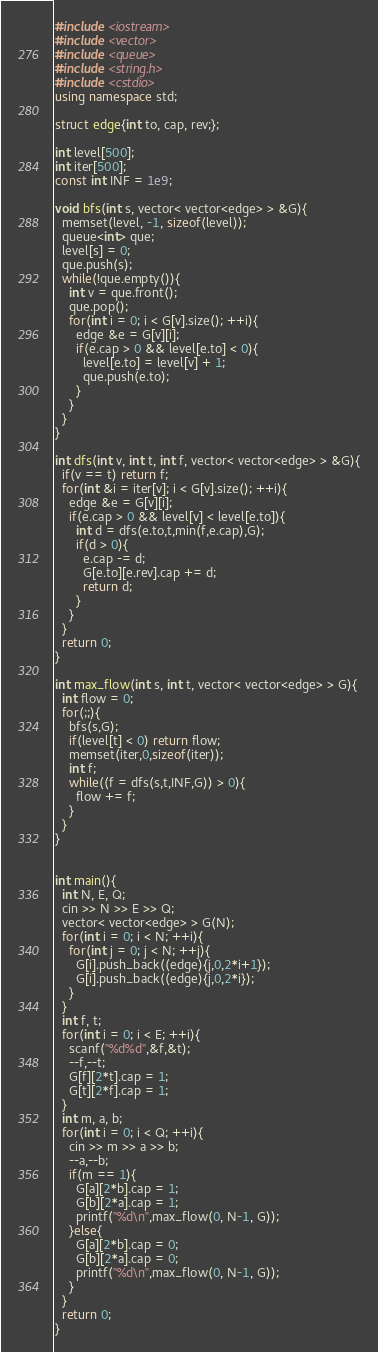<code> <loc_0><loc_0><loc_500><loc_500><_C++_>#include <iostream>
#include <vector>
#include <queue>
#include <string.h>
#include <cstdio>
using namespace std;

struct edge{int to, cap, rev;};

int level[500];
int iter[500];
const int INF = 1e9;

void bfs(int s, vector< vector<edge> > &G){
  memset(level, -1, sizeof(level));
  queue<int> que;
  level[s] = 0;
  que.push(s);
  while(!que.empty()){
    int v = que.front();
    que.pop();
    for(int i = 0; i < G[v].size(); ++i){
      edge &e = G[v][i];
      if(e.cap > 0 && level[e.to] < 0){
        level[e.to] = level[v] + 1;
        que.push(e.to);
      }
    }
  }
}

int dfs(int v, int t, int f, vector< vector<edge> > &G){
  if(v == t) return f;
  for(int &i = iter[v]; i < G[v].size(); ++i){
    edge &e = G[v][i];
    if(e.cap > 0 && level[v] < level[e.to]){
      int d = dfs(e.to,t,min(f,e.cap),G);
      if(d > 0){
        e.cap -= d;
        G[e.to][e.rev].cap += d;
        return d;
      }
    }
  }
  return 0;
}

int max_flow(int s, int t, vector< vector<edge> > G){
  int flow = 0;
  for(;;){
    bfs(s,G);
    if(level[t] < 0) return flow;
    memset(iter,0,sizeof(iter));
    int f;
    while((f = dfs(s,t,INF,G)) > 0){
      flow += f;
    }
  }
}


int main(){
  int N, E, Q;
  cin >> N >> E >> Q;
  vector< vector<edge> > G(N);
  for(int i = 0; i < N; ++i){
    for(int j = 0; j < N; ++j){
      G[i].push_back((edge){j,0,2*i+1});
      G[i].push_back((edge){j,0,2*i});
    }
  }
  int f, t;
  for(int i = 0; i < E; ++i){
    scanf("%d%d",&f,&t);
    --f,--t;
    G[f][2*t].cap = 1;
    G[t][2*f].cap = 1;
  }
  int m, a, b;
  for(int i = 0; i < Q; ++i){
    cin >> m >> a >> b;
    --a,--b;
    if(m == 1){
      G[a][2*b].cap = 1;
      G[b][2*a].cap = 1;
      printf("%d\n",max_flow(0, N-1, G));
    }else{
      G[a][2*b].cap = 0;
      G[b][2*a].cap = 0;
      printf("%d\n",max_flow(0, N-1, G));
    }
  }
  return 0;
}

</code> 